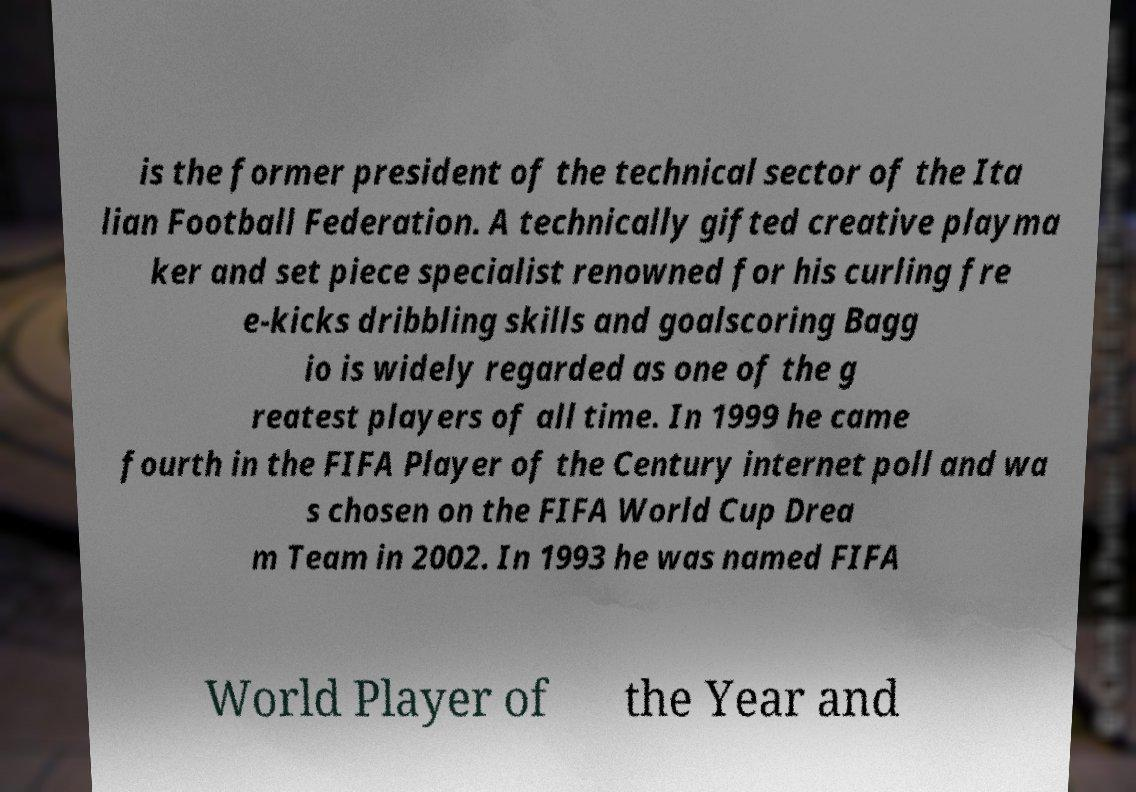Could you extract and type out the text from this image? is the former president of the technical sector of the Ita lian Football Federation. A technically gifted creative playma ker and set piece specialist renowned for his curling fre e-kicks dribbling skills and goalscoring Bagg io is widely regarded as one of the g reatest players of all time. In 1999 he came fourth in the FIFA Player of the Century internet poll and wa s chosen on the FIFA World Cup Drea m Team in 2002. In 1993 he was named FIFA World Player of the Year and 